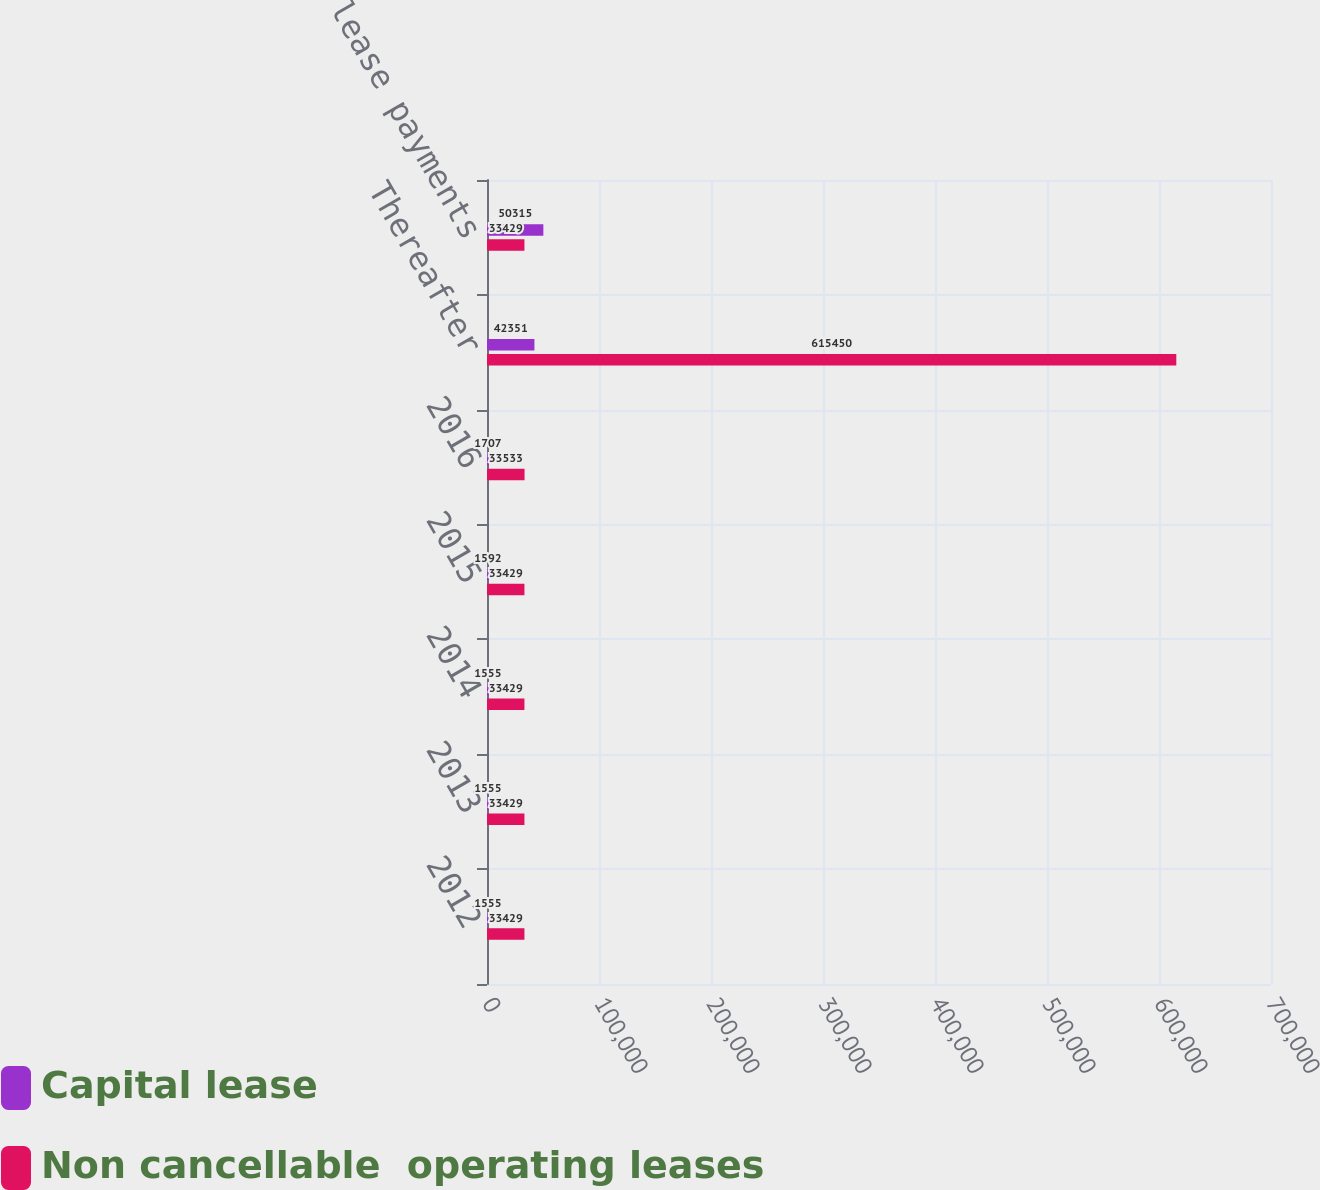<chart> <loc_0><loc_0><loc_500><loc_500><stacked_bar_chart><ecel><fcel>2012<fcel>2013<fcel>2014<fcel>2015<fcel>2016<fcel>Thereafter<fcel>Total minimum lease payments<nl><fcel>Capital lease<fcel>1555<fcel>1555<fcel>1555<fcel>1592<fcel>1707<fcel>42351<fcel>50315<nl><fcel>Non cancellable  operating leases<fcel>33429<fcel>33429<fcel>33429<fcel>33429<fcel>33533<fcel>615450<fcel>33429<nl></chart> 